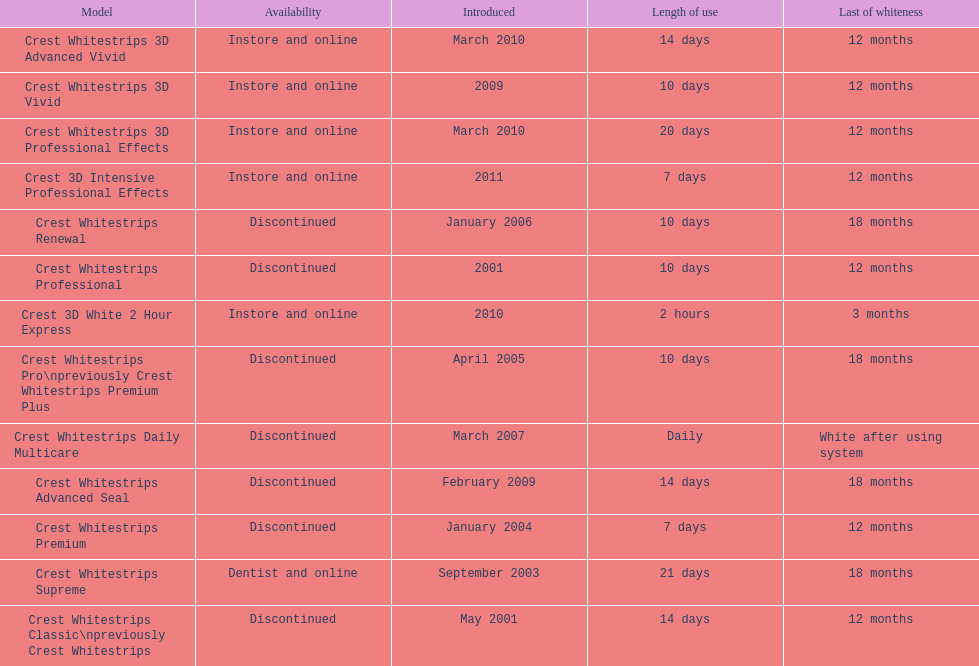Which product was to be used longer, crest whitestrips classic or crest whitestrips 3d vivid? Crest Whitestrips Classic. 